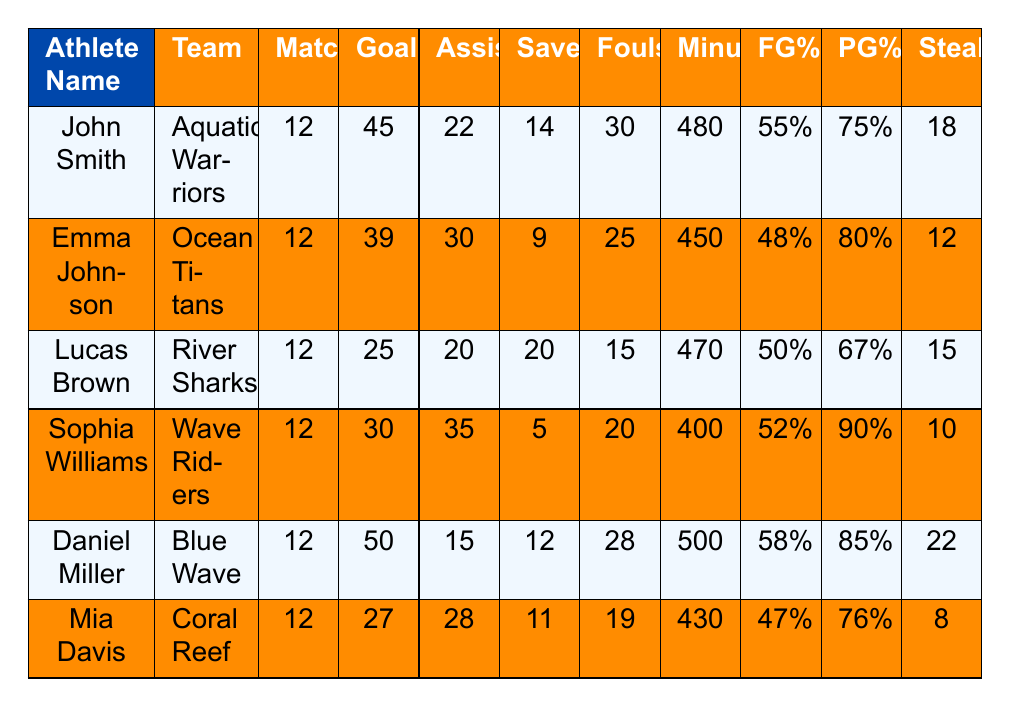What is the highest number of goals scored by an athlete? The table shows that Daniel Miller scored the highest number of goals with 50.
Answer: 50 Which athlete had the highest field goal percentage? Daniel Miller has the highest field goal percentage at 58%.
Answer: 58% How many assists did Sophia Williams make? The table lists Sophia Williams with 35 assists.
Answer: 35 Which athlete committed the fewest fouls? Lucas Brown committed the fewest fouls with only 15.
Answer: 15 What is the total number of goals scored by all athletes in the table? Adding up the goals: 45 + 39 + 25 + 30 + 50 + 27 = 216.
Answer: 216 Did any athlete have a penalty goals percentage of 90%? Yes, Sophia Williams had a penalty goals percentage of 90%.
Answer: Yes Which athlete played the most minutes in the championship? Daniel Miller played 500 minutes, which is the most among all athletes.
Answer: 500 What is the average number of assists among all athletes? The total assists are 22 + 30 + 20 + 35 + 15 + 28 = 150. Since there are 6 athletes, the average is 150 / 6 = 25.
Answer: 25 How many total saves were made by all athletes? Total saves are 14 + 9 + 20 + 5 + 12 + 11 = 71.
Answer: 71 Which athlete had the lowest number of steals? Mia Davis recorded the lowest number of steals with 8.
Answer: 8 If you combined the goals and assists of Emma Johnson, what would that total be? Emma Johnson scored 39 goals and made 30 assists, totaling 39 + 30 = 69.
Answer: 69 